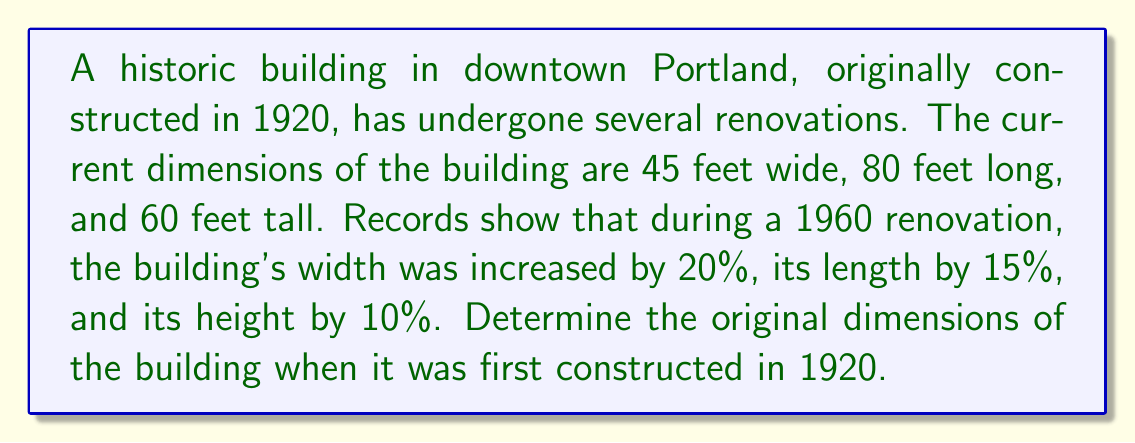Could you help me with this problem? To solve this inverse problem, we need to work backwards from the current dimensions to the original ones. Let's approach this step-by-step:

1. Define variables:
   Let $w$, $l$, and $h$ be the original width, length, and height respectively.

2. Set up equations based on the given information:
   Current width: $45 = w \times 1.20$
   Current length: $80 = l \times 1.15$
   Current height: $60 = h \times 1.10$

3. Solve for the original dimensions:

   For width:
   $w = 45 \div 1.20 = 37.5$ feet

   For length:
   $l = 80 \div 1.15 \approx 69.57$ feet

   For height:
   $h = 60 \div 1.10 \approx 54.55$ feet

4. Round to the nearest foot, as it's unlikely the original measurements were more precise:
   Width: 38 feet
   Length: 70 feet
   Height: 55 feet

These dimensions provide a realistic representation of the building's original size, consistent with early 20th-century architecture in Portland.
Answer: 38 feet wide, 70 feet long, 55 feet tall 